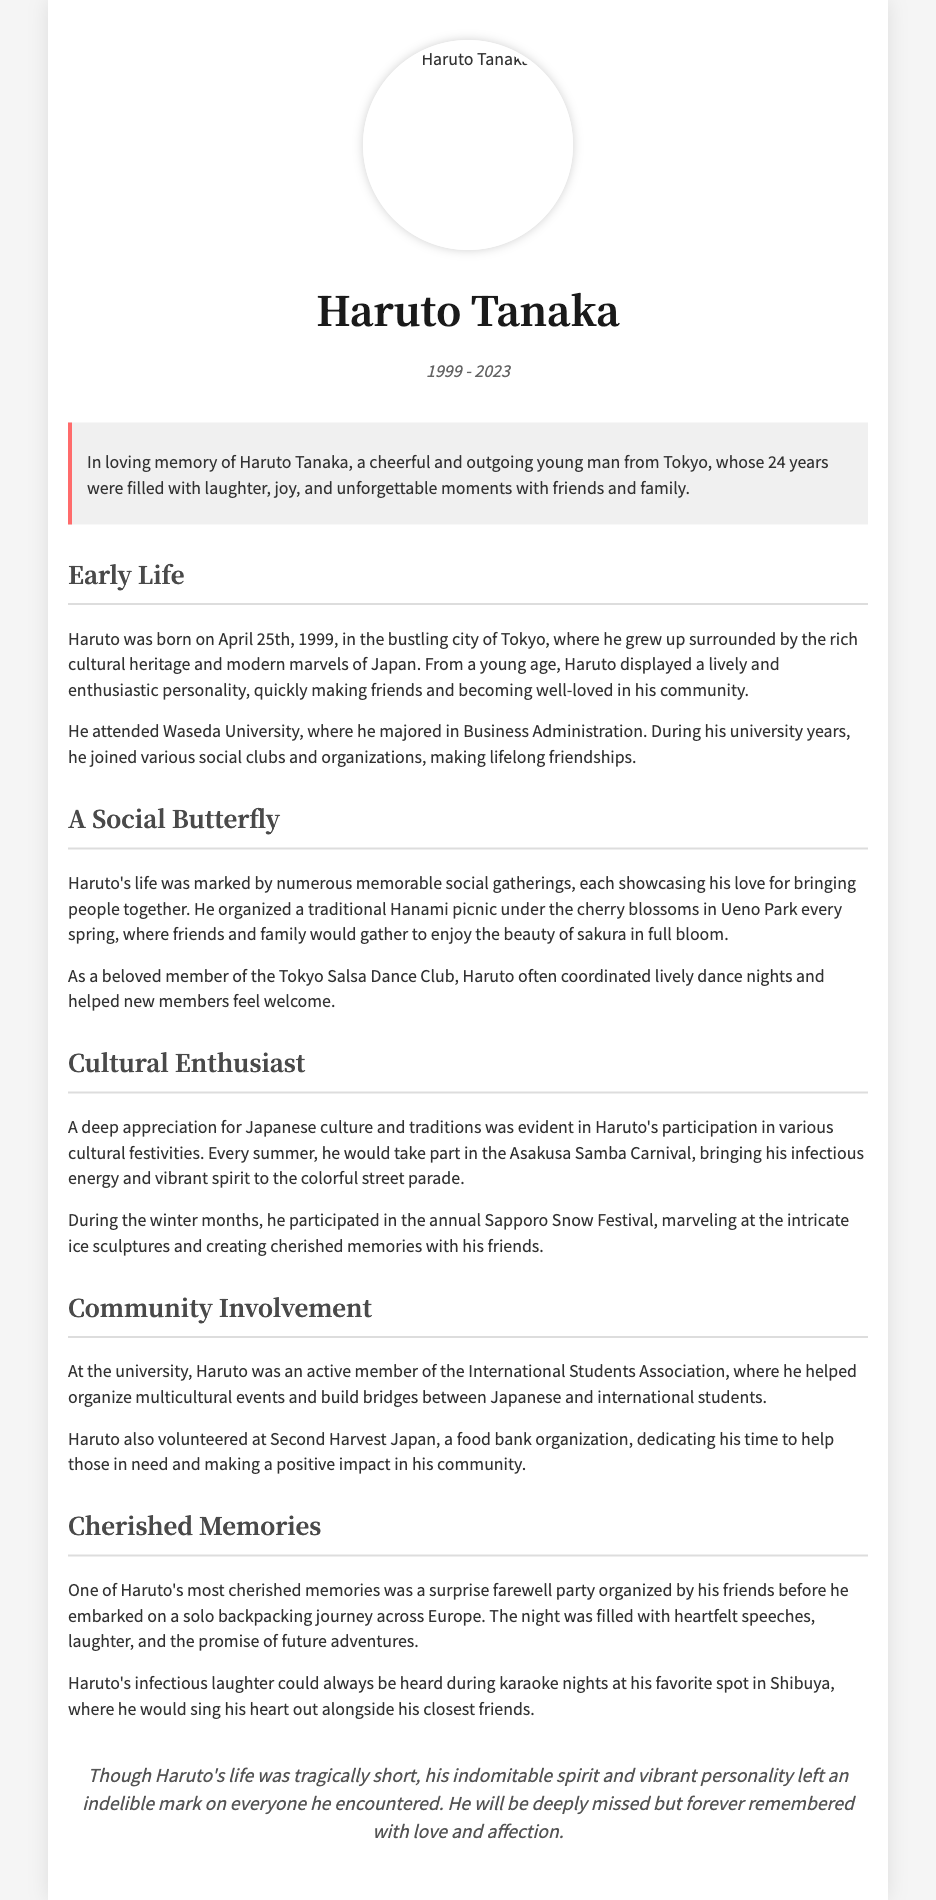What is Haruto Tanaka's birthdate? Haruto was born on April 25th, 1999, as mentioned in the Early Life section.
Answer: April 25th, 1999 Where did Haruto attend university? The document states that he attended Waseda University.
Answer: Waseda University What event did Haruto organize every spring? The text mentions that he organized a traditional Hanami picnic.
Answer: Hanami picnic Which dance club was Haruto a member of? The document specifies that he was a member of the Tokyo Salsa Dance Club.
Answer: Tokyo Salsa Dance Club What festival did Haruto participate in every summer? The text notes that he took part in the Asakusa Samba Carnival each summer.
Answer: Asakusa Samba Carnival What was one of Haruto's favorite activities with friends? The document highlights karaoke nights as one of his favorite activities.
Answer: Karaoke nights What role did Haruto have in the International Students Association? He was an active member who helped organize multicultural events.
Answer: Active member What significant event was organized for Haruto before his European trip? The document mentions a surprise farewell party organized by his friends.
Answer: Farewell party Which organization did Haruto volunteer for? The document states that he volunteered at Second Harvest Japan.
Answer: Second Harvest Japan 